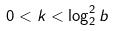Convert formula to latex. <formula><loc_0><loc_0><loc_500><loc_500>0 < k < \log _ { 2 } ^ { 2 } b</formula> 